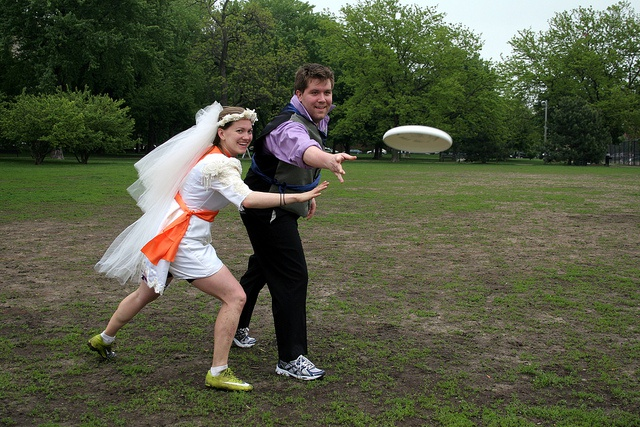Describe the objects in this image and their specific colors. I can see people in black, lightgray, darkgray, and gray tones, people in black, gray, brown, and darkgreen tones, and frisbee in black, gray, white, and darkgray tones in this image. 